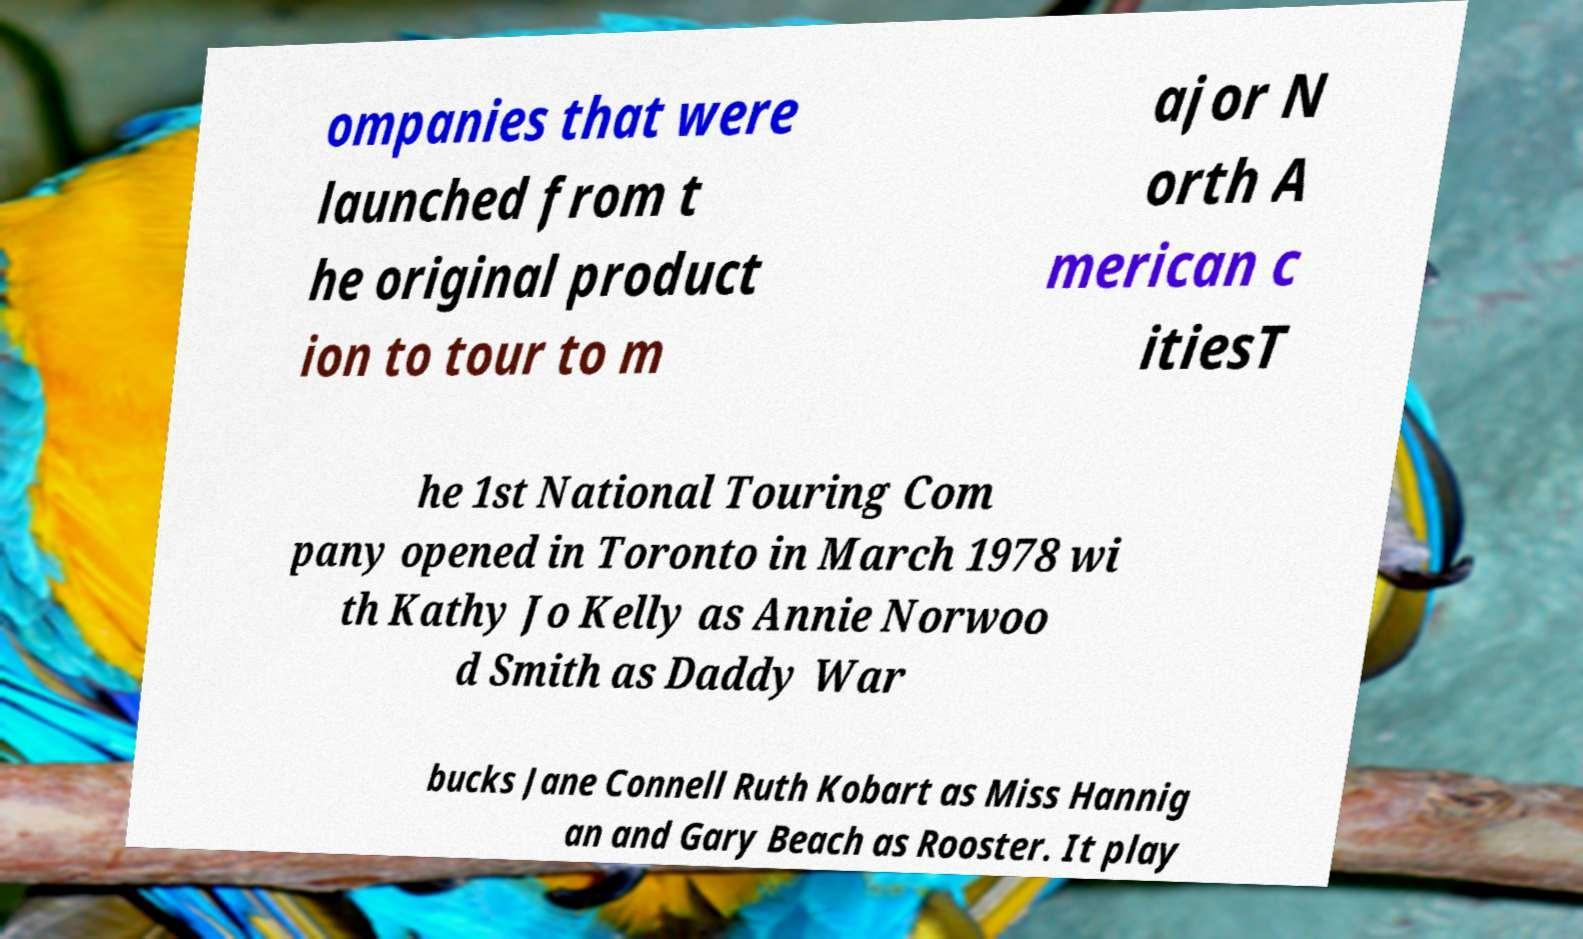Could you assist in decoding the text presented in this image and type it out clearly? ompanies that were launched from t he original product ion to tour to m ajor N orth A merican c itiesT he 1st National Touring Com pany opened in Toronto in March 1978 wi th Kathy Jo Kelly as Annie Norwoo d Smith as Daddy War bucks Jane Connell Ruth Kobart as Miss Hannig an and Gary Beach as Rooster. It play 